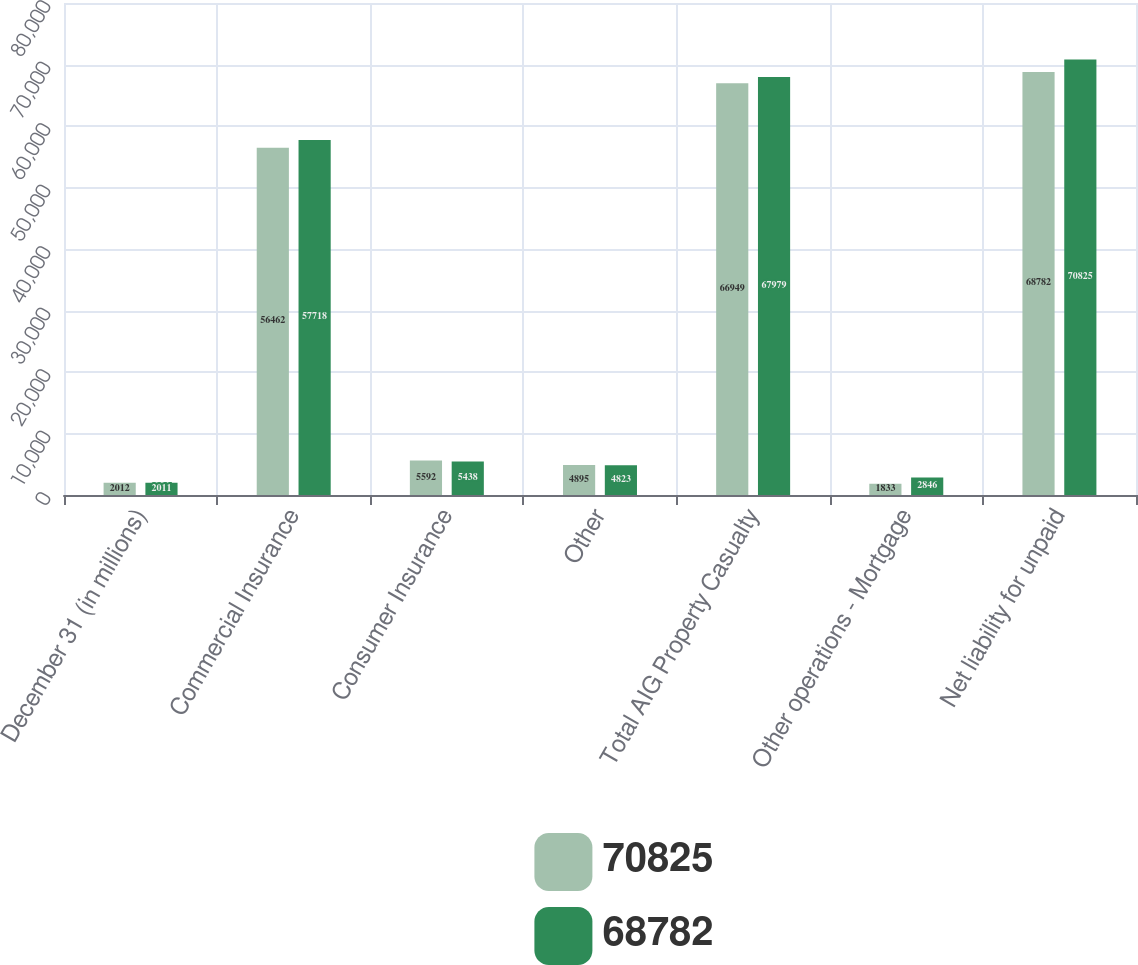Convert chart to OTSL. <chart><loc_0><loc_0><loc_500><loc_500><stacked_bar_chart><ecel><fcel>December 31 (in millions)<fcel>Commercial Insurance<fcel>Consumer Insurance<fcel>Other<fcel>Total AIG Property Casualty<fcel>Other operations - Mortgage<fcel>Net liability for unpaid<nl><fcel>70825<fcel>2012<fcel>56462<fcel>5592<fcel>4895<fcel>66949<fcel>1833<fcel>68782<nl><fcel>68782<fcel>2011<fcel>57718<fcel>5438<fcel>4823<fcel>67979<fcel>2846<fcel>70825<nl></chart> 